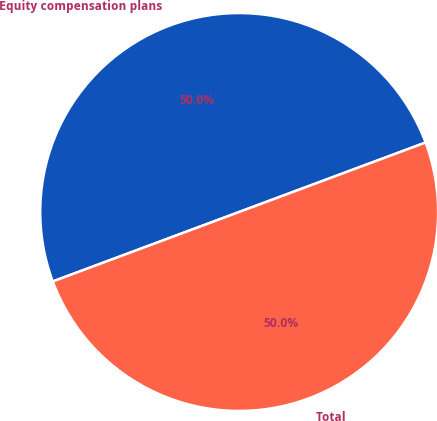Convert chart to OTSL. <chart><loc_0><loc_0><loc_500><loc_500><pie_chart><fcel>Equity compensation plans<fcel>Total<nl><fcel>50.0%<fcel>50.0%<nl></chart> 